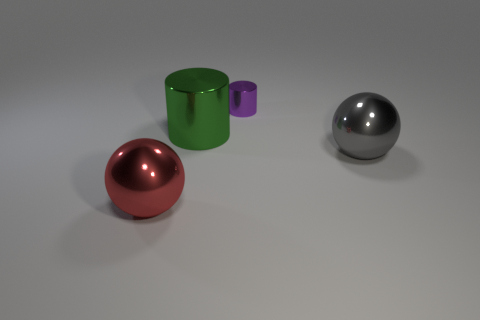There is a large sphere that is left of the tiny purple thing; what material is it?
Make the answer very short. Metal. There is a purple shiny object behind the big red thing; is its shape the same as the large green metallic object behind the red metal object?
Make the answer very short. Yes. Is there a green metallic object?
Provide a succinct answer. Yes. What is the material of the other thing that is the same shape as the tiny shiny object?
Your answer should be very brief. Metal. Are there any big spheres behind the tiny purple metallic object?
Offer a terse response. No. Are the thing to the left of the large green metal object and the small purple thing made of the same material?
Give a very brief answer. Yes. What is the shape of the small metallic thing?
Give a very brief answer. Cylinder. There is a ball that is left of the big gray shiny thing that is on the right side of the purple cylinder; what is its color?
Ensure brevity in your answer.  Red. How big is the thing to the right of the small purple metallic object?
Ensure brevity in your answer.  Large. Is there a big cylinder that has the same material as the large gray sphere?
Make the answer very short. Yes. 